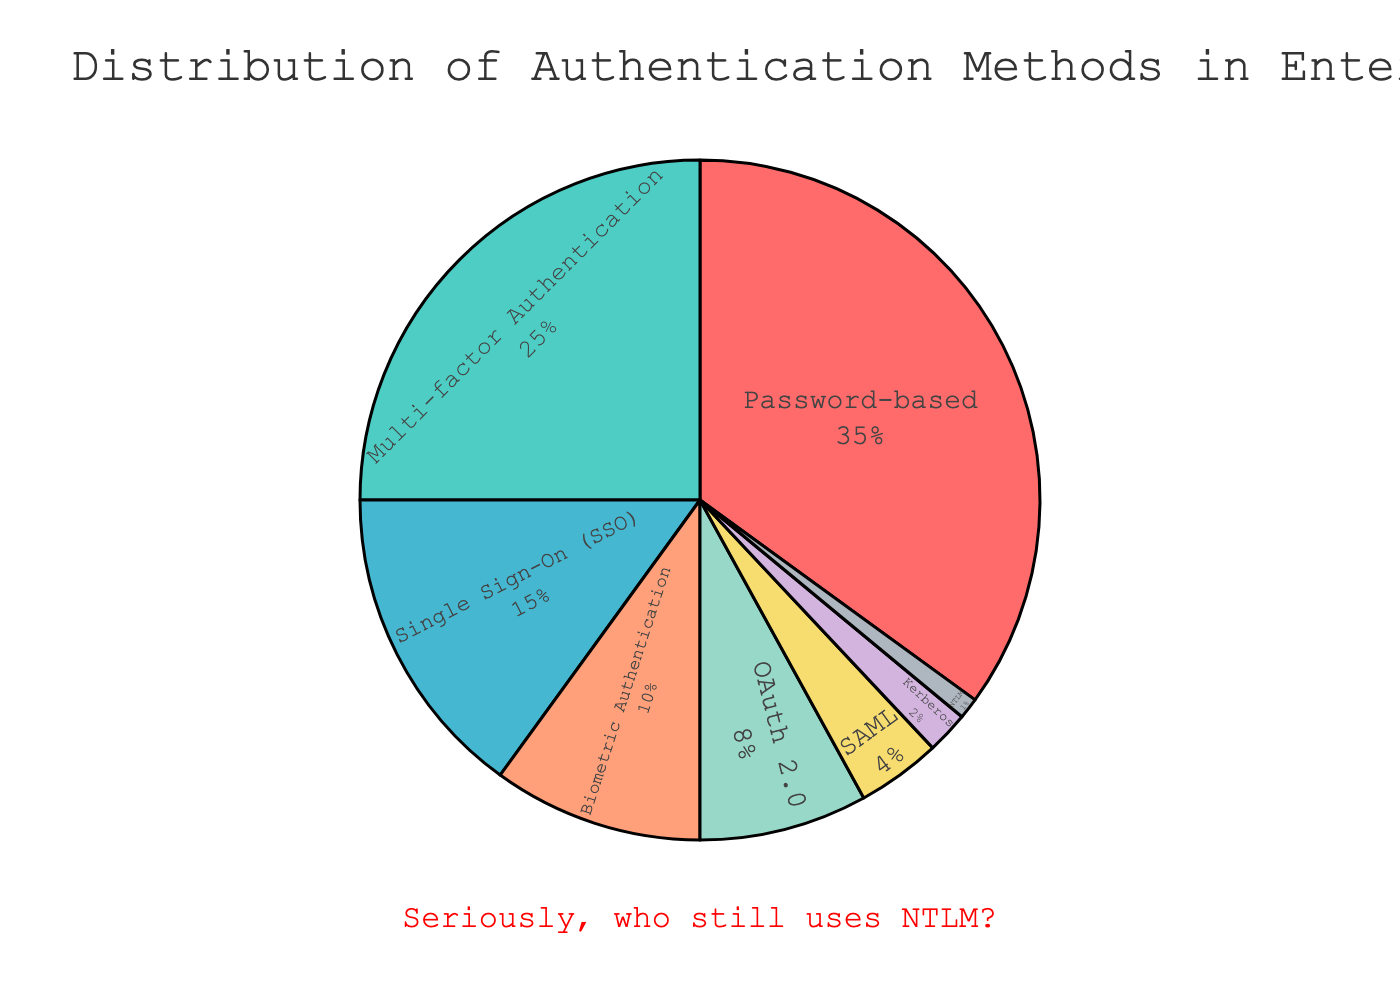Which authentication method is used the most? The pie chart shows various sections representing the percentage of each authentication method used in enterprise applications. The largest section signifies the most used method, which is ‘Password-based’ with 35%.
Answer: Password-based Which method is less prevalent, OAuth 2.0 or SAML? The pie chart displays OAuth 2.0 having 8% and SAML having 4%. Comparing these two, SAML has the lower percentage.
Answer: SAML What’s the combined percentage of Password-based and Multi-factor Authentication methods? Adding the percentages of Password-based (35%) and Multi-factor Authentication (25%) gives the combined usage percentage. Thus, 35% + 25% = 60%.
Answer: 60% Which segment is marked with red color, and what percentage does it represent? The pie chart's color cue given in the task indicates that the red color represents 'Password-based' authentication. Observing the percentage associated with this, ‘Password-based’ is at 35%.
Answer: Password-based, 35% How does Biometric Authentication compare to Single Sign-On (SSO) in terms of percentage? Biometric Authentication has 10%, while Single Sign-On (SSO) has 15%. Therefore, SSO has a higher percentage than Biometric Authentication.
Answer: SSO has a higher percentage If we exclude Password-based, does Multi-factor Authentication make up more than half of the remaining methods' usage? Removing the Password-based percentage (35%) from the total (100%), we have 65% left. Multi-factor Authentication is 25%, so calculating (25/65) * 100 = approximately 38.46%, which is less than half.
Answer: No How much more prevalent is Multi-factor Authentication compared to Kerberos? Multi-factor Authentication stands at 25%, while Kerberos is at 2%. The difference is 25% - 2% = 23%.
Answer: 23% Which method has a prevalence closest to 10%? From the pie chart, Biometric Authentication is reported at exactly 10%, making it the closest.
Answer: Biometric Authentication Does the SSO method have a greater or smaller usage percentage than Biometric Authentication? Comparing their values, Single Sign-On (15%) has a greater percentage than Biometric Authentication (10%).
Answer: Greater What’s the total percentage of outdated methods including NTLM and Kerberos? Adding the percentages of NTLM (1%) and Kerberos (2%), we get a total of 1% + 2% = 3%.
Answer: 3% 